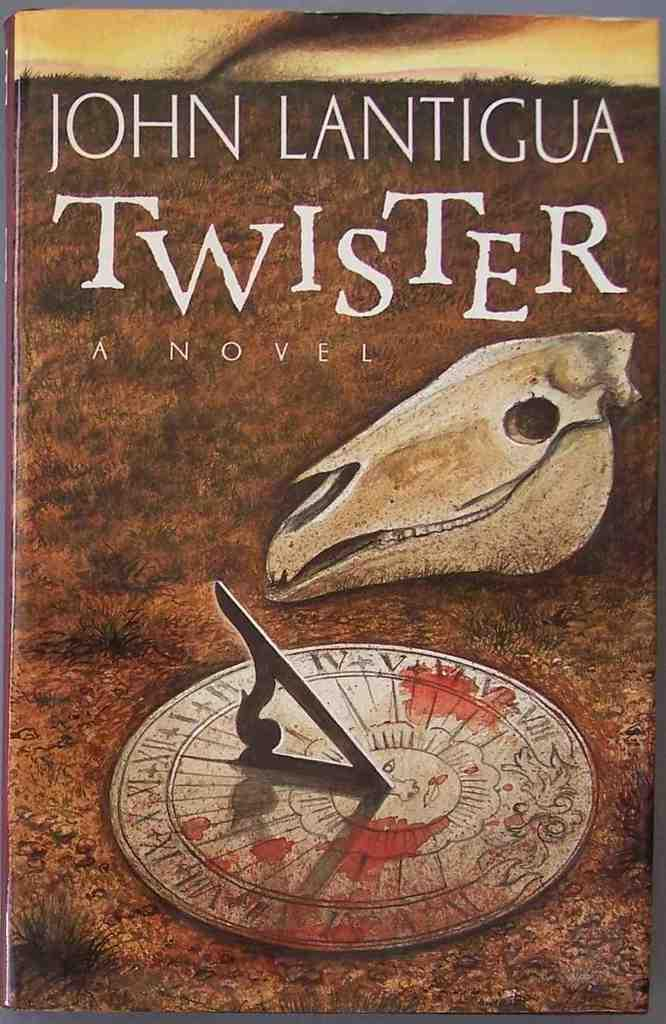What is the main subject of the image? The main subject of the image is the cover page of a book. What can be found on the cover page? There is text and images on the cover page. How many chickens are depicted on the cover page? There are no chickens depicted on the cover page; it features text and images related to the book. What type of sail is visible on the cover page? There is no sail present on the cover page; it only contains text and images related to the book. 